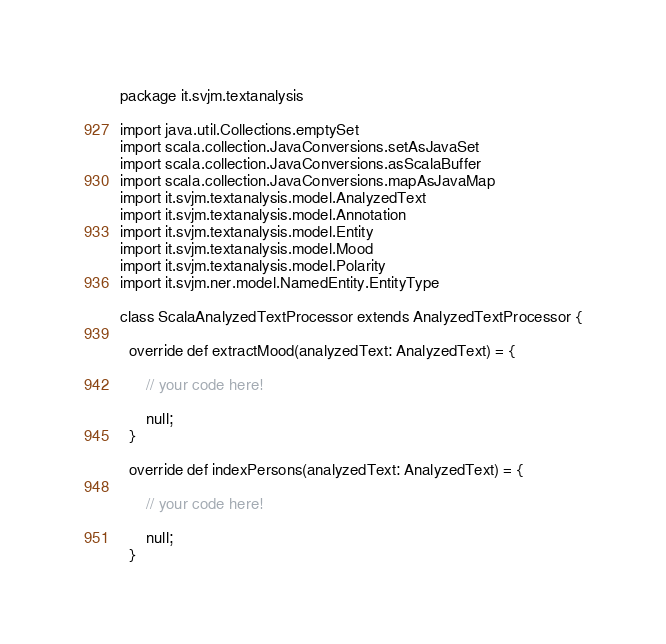Convert code to text. <code><loc_0><loc_0><loc_500><loc_500><_Scala_>package it.svjm.textanalysis

import java.util.Collections.emptySet
import scala.collection.JavaConversions.setAsJavaSet
import scala.collection.JavaConversions.asScalaBuffer
import scala.collection.JavaConversions.mapAsJavaMap
import it.svjm.textanalysis.model.AnalyzedText
import it.svjm.textanalysis.model.Annotation
import it.svjm.textanalysis.model.Entity
import it.svjm.textanalysis.model.Mood
import it.svjm.textanalysis.model.Polarity
import it.svjm.ner.model.NamedEntity.EntityType

class ScalaAnalyzedTextProcessor extends AnalyzedTextProcessor {

  override def extractMood(analyzedText: AnalyzedText) = {
      
      // your code here!
      
      null;
  }

  override def indexPersons(analyzedText: AnalyzedText) = {
      
      // your code here!
      
      null;
  }
</code> 